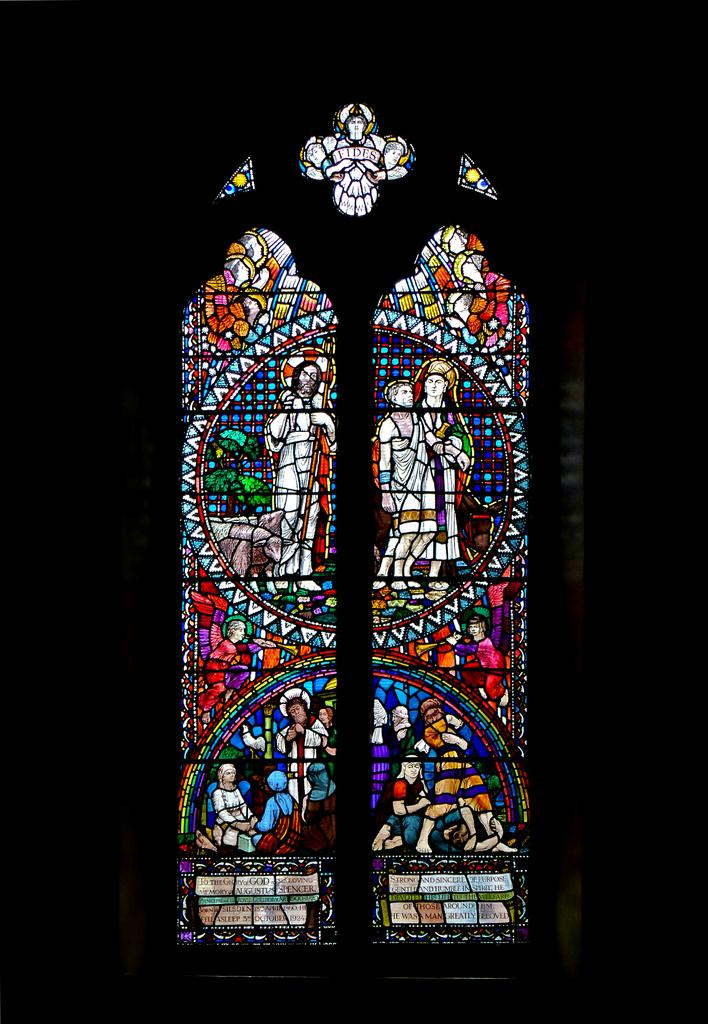What type of glass is depicted in the image? There is a stained glass in the image. What can be observed about the background of the image? The background of the image is dark. How many chickens are present on the tray in the image? There are no chickens or trays present in the image; it only features a stained glass with a dark background. 